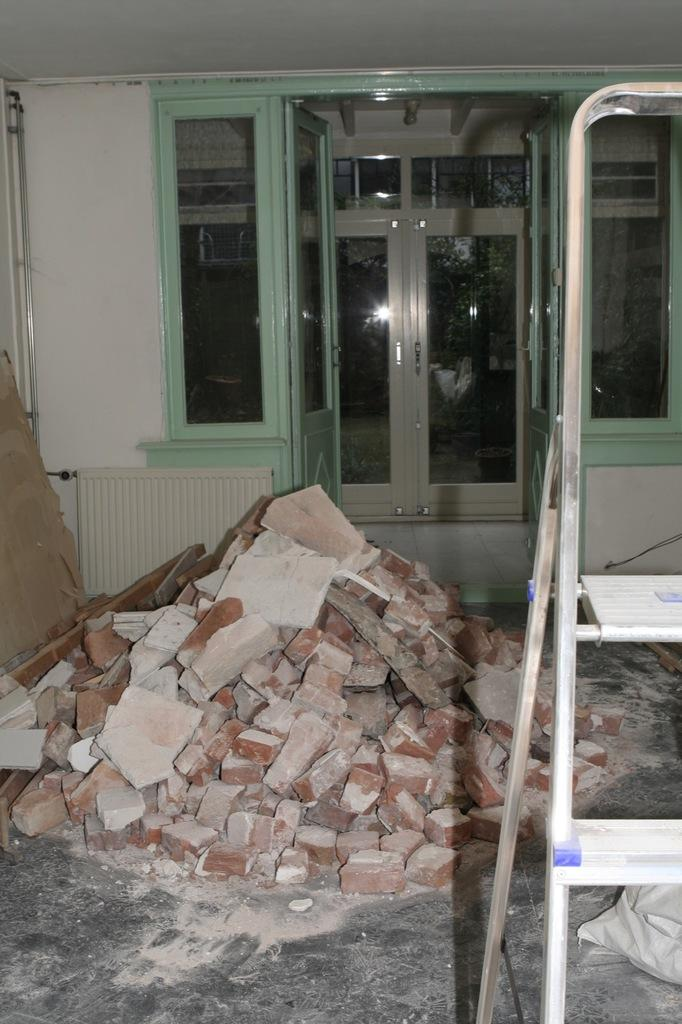What is the main object in the foreground of the image? There is a ladder in the image. What type of building material can be seen in the image? There are bricks in the image. What architectural features are visible in the background of the image? There is a door, a window, and a wall in the background of the image. What is the rate of the bite marks on the ladder in the image? There are no bite marks present on the ladder in the image. 